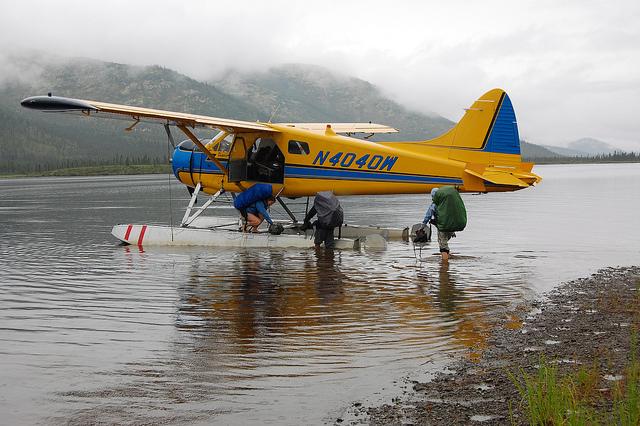Did the plane land in the water?
Keep it brief. Yes. Can this yellow plane sail the water as well?
Be succinct. Yes. Are the people painting a wall?
Answer briefly. No. 